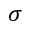Convert formula to latex. <formula><loc_0><loc_0><loc_500><loc_500>\sigma</formula> 